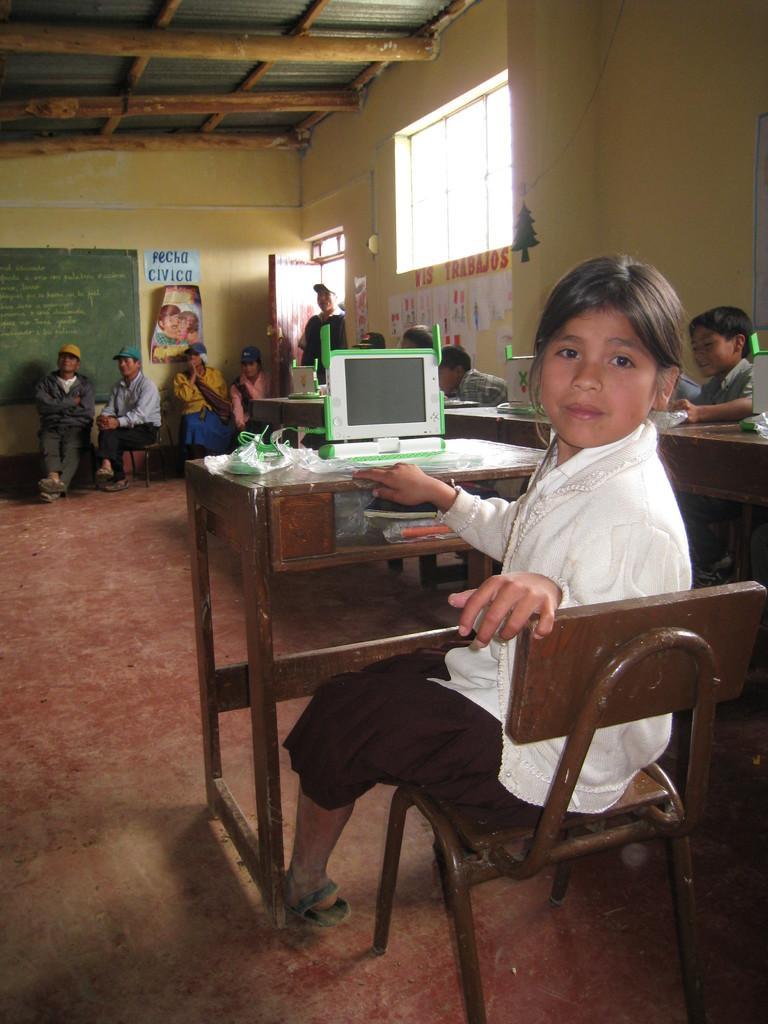Please provide a concise description of this image. As we can see in the image there are few people sitting on chairs. In front of them there is a table and laptop over here and there is a yellow color wall over here. 